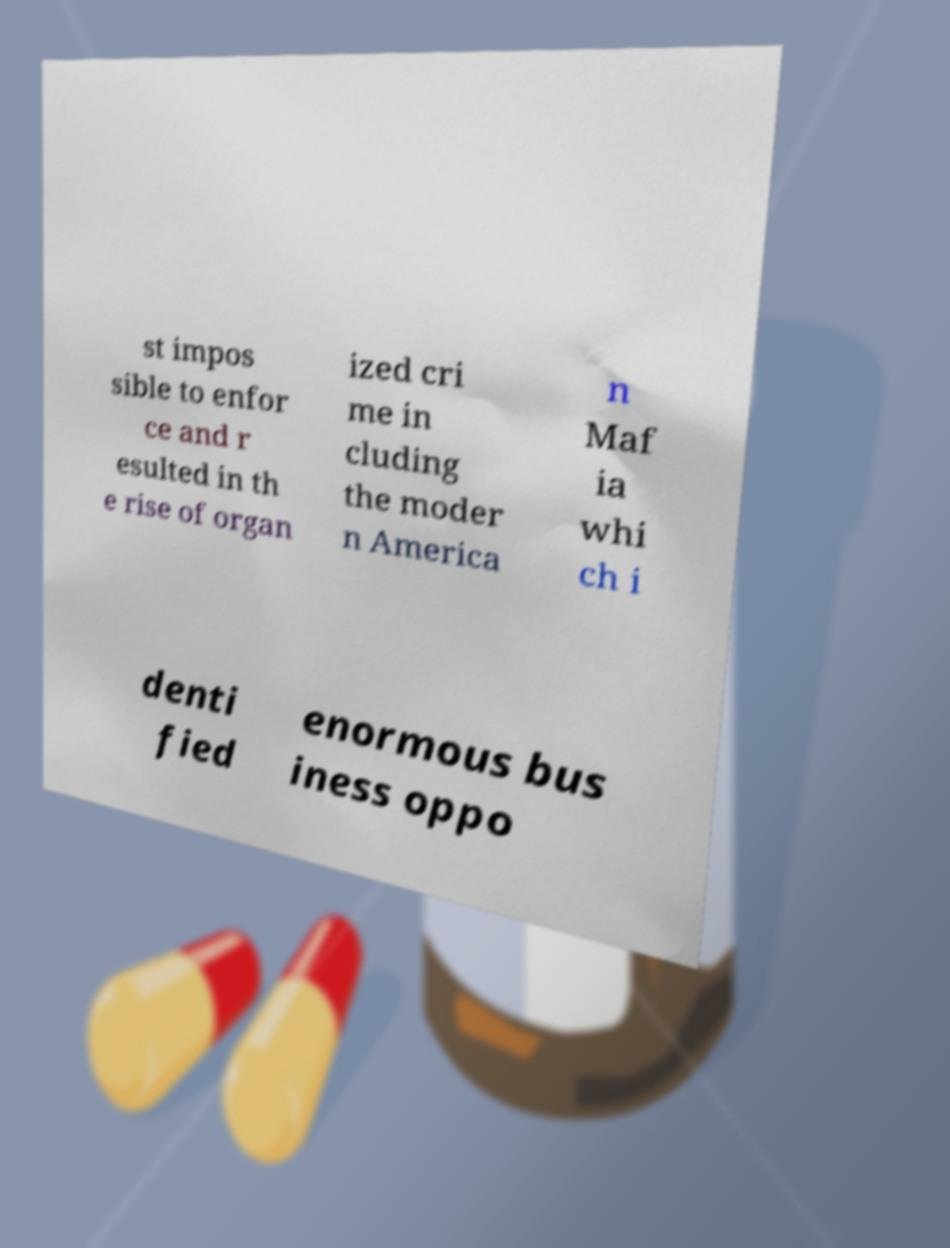Please read and relay the text visible in this image. What does it say? st impos sible to enfor ce and r esulted in th e rise of organ ized cri me in cluding the moder n America n Maf ia whi ch i denti fied enormous bus iness oppo 